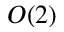Convert formula to latex. <formula><loc_0><loc_0><loc_500><loc_500>O ( 2 )</formula> 